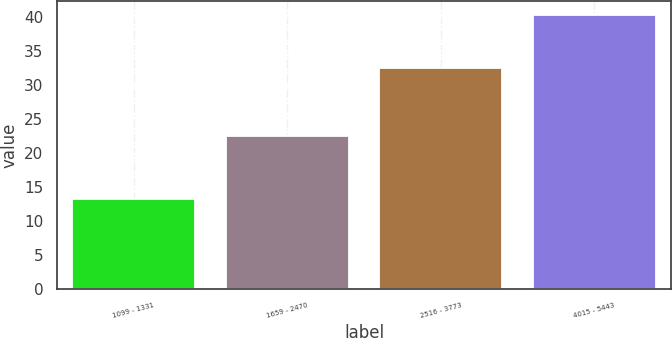Convert chart to OTSL. <chart><loc_0><loc_0><loc_500><loc_500><bar_chart><fcel>1099 - 1331<fcel>1659 - 2470<fcel>2516 - 3773<fcel>4015 - 5443<nl><fcel>13.15<fcel>22.48<fcel>32.42<fcel>40.27<nl></chart> 